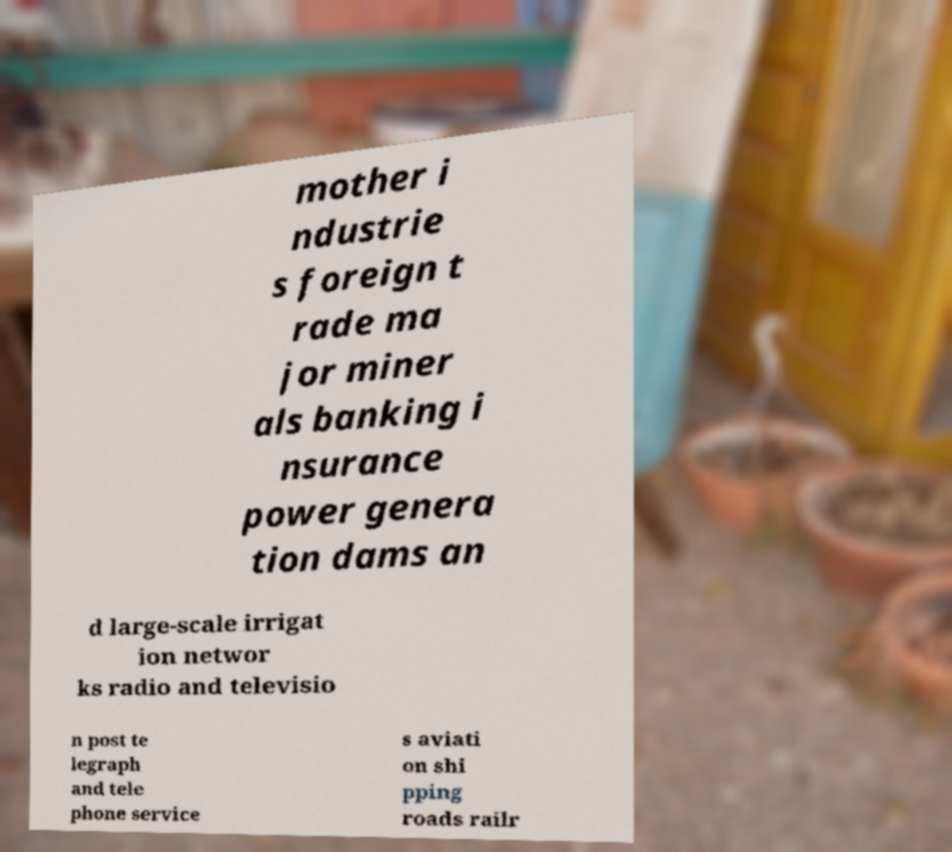For documentation purposes, I need the text within this image transcribed. Could you provide that? mother i ndustrie s foreign t rade ma jor miner als banking i nsurance power genera tion dams an d large-scale irrigat ion networ ks radio and televisio n post te legraph and tele phone service s aviati on shi pping roads railr 